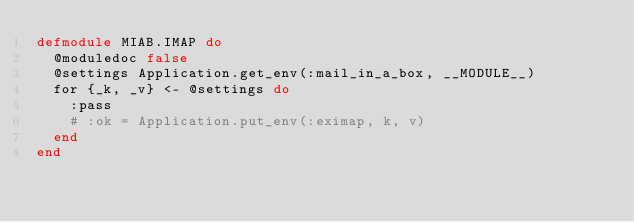<code> <loc_0><loc_0><loc_500><loc_500><_Elixir_>defmodule MIAB.IMAP do
  @moduledoc false
  @settings Application.get_env(:mail_in_a_box, __MODULE__)
  for {_k, _v} <- @settings do
    :pass
    # :ok = Application.put_env(:eximap, k, v)
  end
end
</code> 